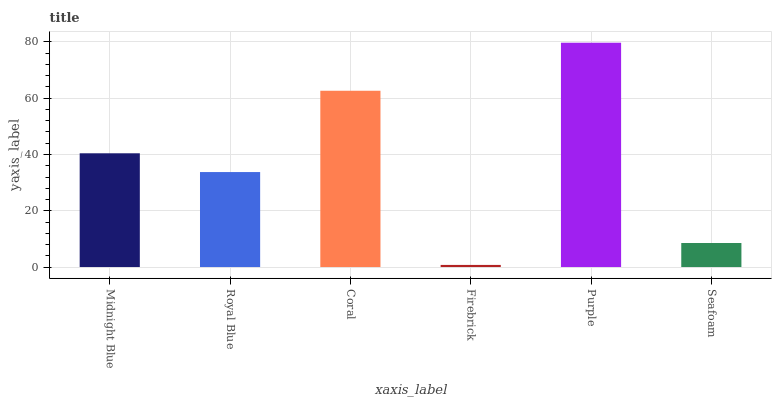Is Firebrick the minimum?
Answer yes or no. Yes. Is Purple the maximum?
Answer yes or no. Yes. Is Royal Blue the minimum?
Answer yes or no. No. Is Royal Blue the maximum?
Answer yes or no. No. Is Midnight Blue greater than Royal Blue?
Answer yes or no. Yes. Is Royal Blue less than Midnight Blue?
Answer yes or no. Yes. Is Royal Blue greater than Midnight Blue?
Answer yes or no. No. Is Midnight Blue less than Royal Blue?
Answer yes or no. No. Is Midnight Blue the high median?
Answer yes or no. Yes. Is Royal Blue the low median?
Answer yes or no. Yes. Is Purple the high median?
Answer yes or no. No. Is Midnight Blue the low median?
Answer yes or no. No. 